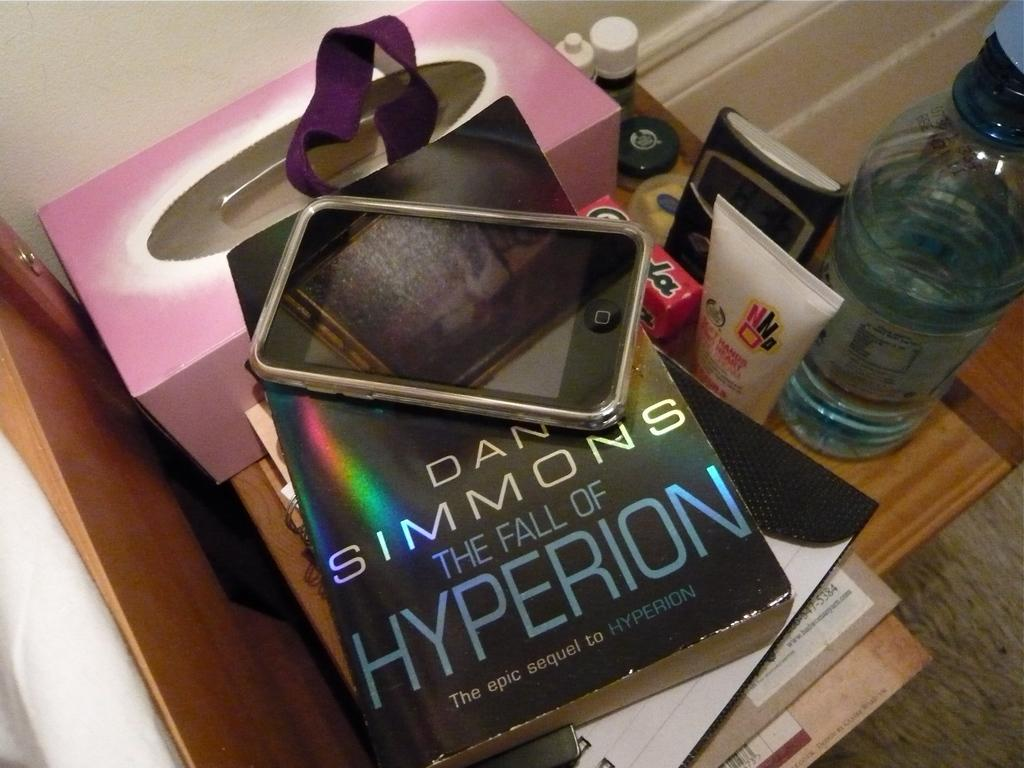<image>
Describe the image concisely. An iPod sit on a the book The Fall of Hyperion by Dan Simmons. 